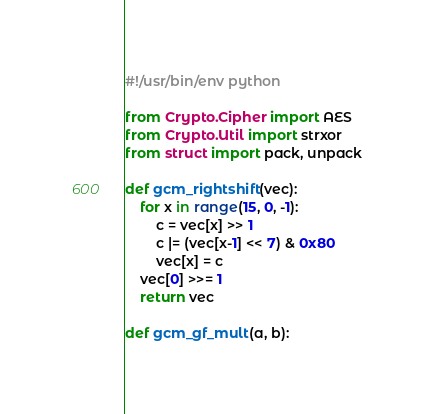<code> <loc_0><loc_0><loc_500><loc_500><_Python_>#!/usr/bin/env python

from Crypto.Cipher import AES
from Crypto.Util import strxor
from struct import pack, unpack

def gcm_rightshift(vec):
    for x in range(15, 0, -1):
        c = vec[x] >> 1
        c |= (vec[x-1] << 7) & 0x80
        vec[x] = c
    vec[0] >>= 1
    return vec

def gcm_gf_mult(a, b):</code> 